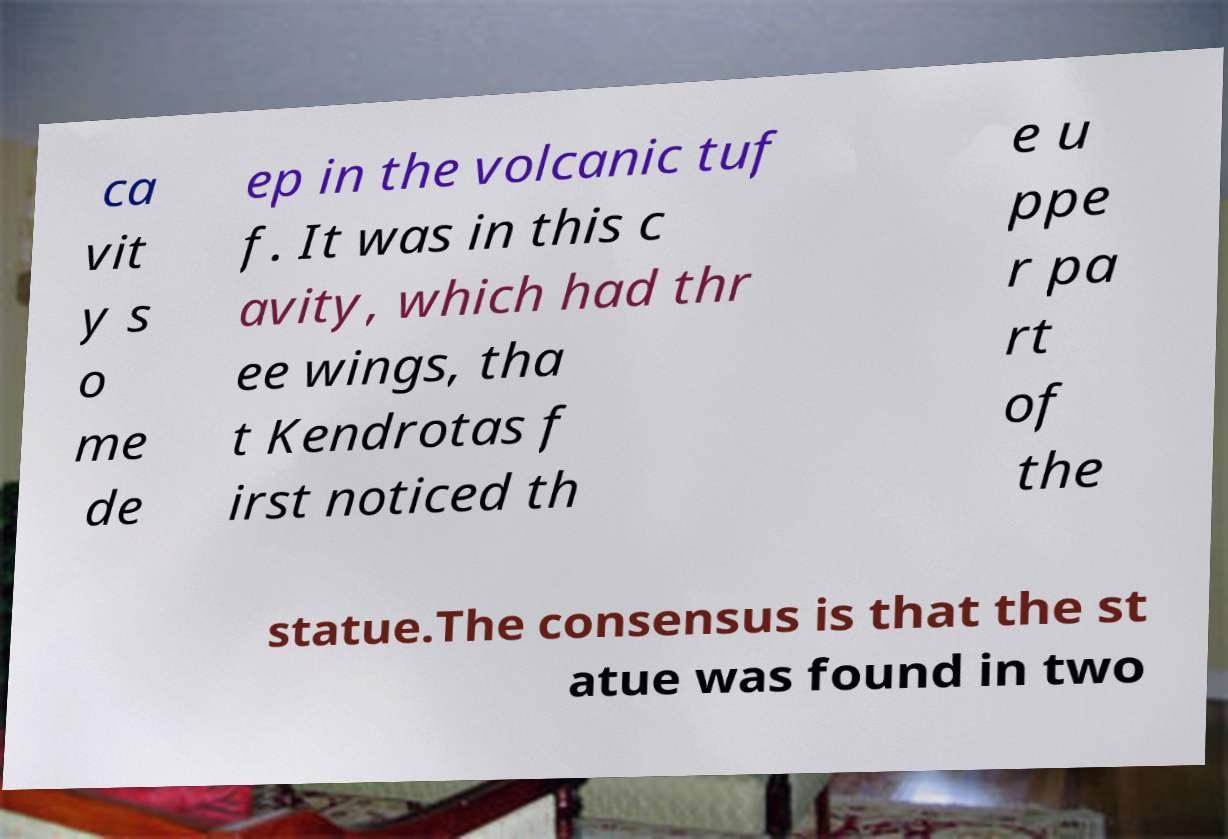Could you extract and type out the text from this image? ca vit y s o me de ep in the volcanic tuf f. It was in this c avity, which had thr ee wings, tha t Kendrotas f irst noticed th e u ppe r pa rt of the statue.The consensus is that the st atue was found in two 